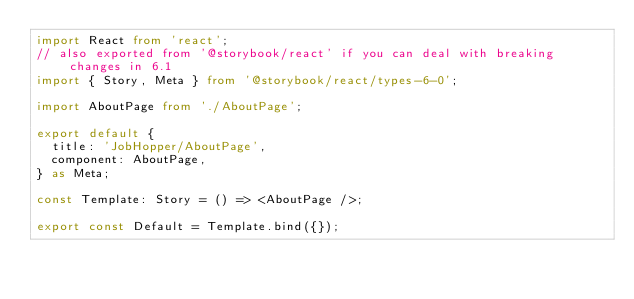<code> <loc_0><loc_0><loc_500><loc_500><_TypeScript_>import React from 'react';
// also exported from '@storybook/react' if you can deal with breaking changes in 6.1
import { Story, Meta } from '@storybook/react/types-6-0';

import AboutPage from './AboutPage';

export default {
  title: 'JobHopper/AboutPage',
  component: AboutPage,
} as Meta;

const Template: Story = () => <AboutPage />;

export const Default = Template.bind({});
</code> 